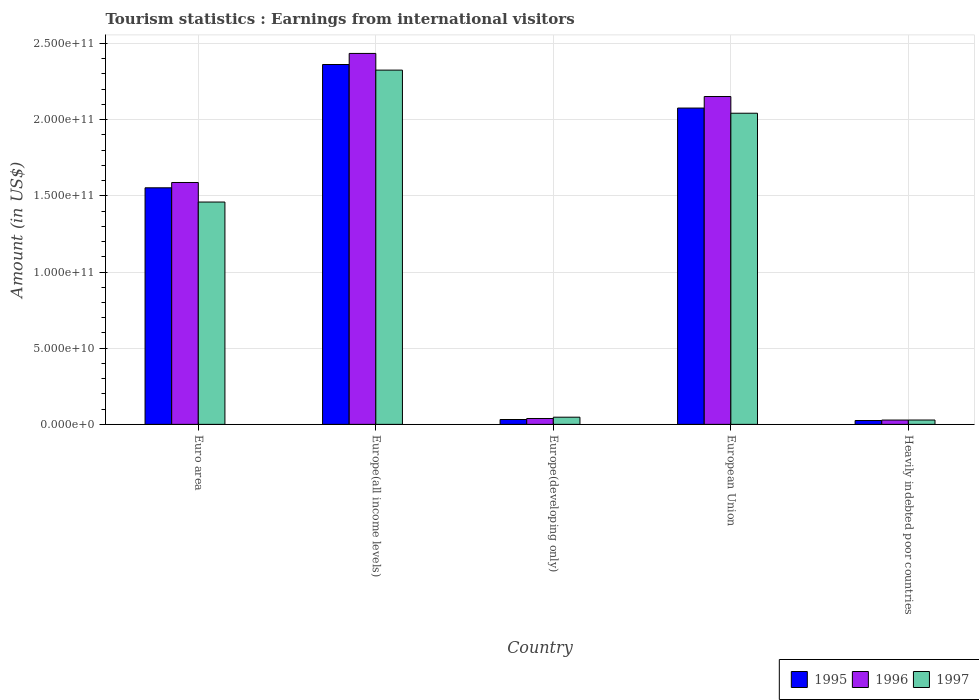How many groups of bars are there?
Ensure brevity in your answer.  5. Are the number of bars on each tick of the X-axis equal?
Your answer should be compact. Yes. What is the label of the 5th group of bars from the left?
Your answer should be very brief. Heavily indebted poor countries. What is the earnings from international visitors in 1996 in Europe(developing only)?
Provide a succinct answer. 3.86e+09. Across all countries, what is the maximum earnings from international visitors in 1997?
Keep it short and to the point. 2.33e+11. Across all countries, what is the minimum earnings from international visitors in 1996?
Provide a succinct answer. 2.83e+09. In which country was the earnings from international visitors in 1996 maximum?
Keep it short and to the point. Europe(all income levels). In which country was the earnings from international visitors in 1997 minimum?
Provide a succinct answer. Heavily indebted poor countries. What is the total earnings from international visitors in 1997 in the graph?
Your answer should be compact. 5.90e+11. What is the difference between the earnings from international visitors in 1996 in European Union and that in Heavily indebted poor countries?
Make the answer very short. 2.12e+11. What is the difference between the earnings from international visitors in 1996 in Euro area and the earnings from international visitors in 1997 in Europe(all income levels)?
Ensure brevity in your answer.  -7.38e+1. What is the average earnings from international visitors in 1997 per country?
Provide a short and direct response. 1.18e+11. What is the difference between the earnings from international visitors of/in 1996 and earnings from international visitors of/in 1997 in Heavily indebted poor countries?
Provide a succinct answer. -2.43e+07. In how many countries, is the earnings from international visitors in 1995 greater than 170000000000 US$?
Offer a very short reply. 2. What is the ratio of the earnings from international visitors in 1997 in Europe(developing only) to that in Heavily indebted poor countries?
Your answer should be compact. 1.65. Is the difference between the earnings from international visitors in 1996 in Europe(all income levels) and European Union greater than the difference between the earnings from international visitors in 1997 in Europe(all income levels) and European Union?
Ensure brevity in your answer.  Yes. What is the difference between the highest and the second highest earnings from international visitors in 1997?
Offer a very short reply. -2.83e+1. What is the difference between the highest and the lowest earnings from international visitors in 1995?
Provide a short and direct response. 2.34e+11. In how many countries, is the earnings from international visitors in 1997 greater than the average earnings from international visitors in 1997 taken over all countries?
Ensure brevity in your answer.  3. Is the sum of the earnings from international visitors in 1995 in European Union and Heavily indebted poor countries greater than the maximum earnings from international visitors in 1996 across all countries?
Offer a very short reply. No. What does the 3rd bar from the left in Europe(developing only) represents?
Your answer should be compact. 1997. What does the 1st bar from the right in Europe(developing only) represents?
Your answer should be very brief. 1997. Is it the case that in every country, the sum of the earnings from international visitors in 1995 and earnings from international visitors in 1996 is greater than the earnings from international visitors in 1997?
Ensure brevity in your answer.  Yes. Are all the bars in the graph horizontal?
Provide a short and direct response. No. Are the values on the major ticks of Y-axis written in scientific E-notation?
Make the answer very short. Yes. Does the graph contain grids?
Provide a short and direct response. Yes. Where does the legend appear in the graph?
Your answer should be very brief. Bottom right. How many legend labels are there?
Offer a very short reply. 3. What is the title of the graph?
Keep it short and to the point. Tourism statistics : Earnings from international visitors. What is the label or title of the Y-axis?
Keep it short and to the point. Amount (in US$). What is the Amount (in US$) of 1995 in Euro area?
Give a very brief answer. 1.55e+11. What is the Amount (in US$) in 1996 in Euro area?
Keep it short and to the point. 1.59e+11. What is the Amount (in US$) of 1997 in Euro area?
Your answer should be compact. 1.46e+11. What is the Amount (in US$) of 1995 in Europe(all income levels)?
Your response must be concise. 2.36e+11. What is the Amount (in US$) of 1996 in Europe(all income levels)?
Offer a very short reply. 2.43e+11. What is the Amount (in US$) in 1997 in Europe(all income levels)?
Give a very brief answer. 2.33e+11. What is the Amount (in US$) of 1995 in Europe(developing only)?
Give a very brief answer. 3.19e+09. What is the Amount (in US$) of 1996 in Europe(developing only)?
Offer a terse response. 3.86e+09. What is the Amount (in US$) in 1997 in Europe(developing only)?
Provide a succinct answer. 4.71e+09. What is the Amount (in US$) in 1995 in European Union?
Offer a terse response. 2.08e+11. What is the Amount (in US$) of 1996 in European Union?
Give a very brief answer. 2.15e+11. What is the Amount (in US$) of 1997 in European Union?
Give a very brief answer. 2.04e+11. What is the Amount (in US$) of 1995 in Heavily indebted poor countries?
Provide a short and direct response. 2.53e+09. What is the Amount (in US$) in 1996 in Heavily indebted poor countries?
Give a very brief answer. 2.83e+09. What is the Amount (in US$) in 1997 in Heavily indebted poor countries?
Make the answer very short. 2.86e+09. Across all countries, what is the maximum Amount (in US$) of 1995?
Your answer should be very brief. 2.36e+11. Across all countries, what is the maximum Amount (in US$) of 1996?
Your answer should be very brief. 2.43e+11. Across all countries, what is the maximum Amount (in US$) of 1997?
Your response must be concise. 2.33e+11. Across all countries, what is the minimum Amount (in US$) in 1995?
Your answer should be very brief. 2.53e+09. Across all countries, what is the minimum Amount (in US$) in 1996?
Keep it short and to the point. 2.83e+09. Across all countries, what is the minimum Amount (in US$) in 1997?
Offer a terse response. 2.86e+09. What is the total Amount (in US$) in 1995 in the graph?
Offer a terse response. 6.05e+11. What is the total Amount (in US$) of 1996 in the graph?
Your answer should be very brief. 6.24e+11. What is the total Amount (in US$) of 1997 in the graph?
Offer a very short reply. 5.90e+11. What is the difference between the Amount (in US$) in 1995 in Euro area and that in Europe(all income levels)?
Give a very brief answer. -8.09e+1. What is the difference between the Amount (in US$) in 1996 in Euro area and that in Europe(all income levels)?
Keep it short and to the point. -8.47e+1. What is the difference between the Amount (in US$) in 1997 in Euro area and that in Europe(all income levels)?
Ensure brevity in your answer.  -8.66e+1. What is the difference between the Amount (in US$) in 1995 in Euro area and that in Europe(developing only)?
Give a very brief answer. 1.52e+11. What is the difference between the Amount (in US$) in 1996 in Euro area and that in Europe(developing only)?
Your answer should be very brief. 1.55e+11. What is the difference between the Amount (in US$) of 1997 in Euro area and that in Europe(developing only)?
Keep it short and to the point. 1.41e+11. What is the difference between the Amount (in US$) in 1995 in Euro area and that in European Union?
Provide a short and direct response. -5.23e+1. What is the difference between the Amount (in US$) of 1996 in Euro area and that in European Union?
Offer a terse response. -5.64e+1. What is the difference between the Amount (in US$) of 1997 in Euro area and that in European Union?
Your answer should be very brief. -5.83e+1. What is the difference between the Amount (in US$) of 1995 in Euro area and that in Heavily indebted poor countries?
Give a very brief answer. 1.53e+11. What is the difference between the Amount (in US$) in 1996 in Euro area and that in Heavily indebted poor countries?
Your answer should be compact. 1.56e+11. What is the difference between the Amount (in US$) in 1997 in Euro area and that in Heavily indebted poor countries?
Your response must be concise. 1.43e+11. What is the difference between the Amount (in US$) of 1995 in Europe(all income levels) and that in Europe(developing only)?
Your answer should be very brief. 2.33e+11. What is the difference between the Amount (in US$) of 1996 in Europe(all income levels) and that in Europe(developing only)?
Your response must be concise. 2.40e+11. What is the difference between the Amount (in US$) in 1997 in Europe(all income levels) and that in Europe(developing only)?
Give a very brief answer. 2.28e+11. What is the difference between the Amount (in US$) in 1995 in Europe(all income levels) and that in European Union?
Your answer should be compact. 2.86e+1. What is the difference between the Amount (in US$) in 1996 in Europe(all income levels) and that in European Union?
Provide a short and direct response. 2.83e+1. What is the difference between the Amount (in US$) of 1997 in Europe(all income levels) and that in European Union?
Offer a terse response. 2.83e+1. What is the difference between the Amount (in US$) of 1995 in Europe(all income levels) and that in Heavily indebted poor countries?
Keep it short and to the point. 2.34e+11. What is the difference between the Amount (in US$) of 1996 in Europe(all income levels) and that in Heavily indebted poor countries?
Keep it short and to the point. 2.41e+11. What is the difference between the Amount (in US$) in 1997 in Europe(all income levels) and that in Heavily indebted poor countries?
Keep it short and to the point. 2.30e+11. What is the difference between the Amount (in US$) of 1995 in Europe(developing only) and that in European Union?
Provide a short and direct response. -2.04e+11. What is the difference between the Amount (in US$) in 1996 in Europe(developing only) and that in European Union?
Your response must be concise. -2.11e+11. What is the difference between the Amount (in US$) in 1997 in Europe(developing only) and that in European Union?
Offer a very short reply. -2.00e+11. What is the difference between the Amount (in US$) of 1995 in Europe(developing only) and that in Heavily indebted poor countries?
Make the answer very short. 6.57e+08. What is the difference between the Amount (in US$) of 1996 in Europe(developing only) and that in Heavily indebted poor countries?
Your answer should be very brief. 1.02e+09. What is the difference between the Amount (in US$) of 1997 in Europe(developing only) and that in Heavily indebted poor countries?
Ensure brevity in your answer.  1.85e+09. What is the difference between the Amount (in US$) of 1995 in European Union and that in Heavily indebted poor countries?
Your answer should be very brief. 2.05e+11. What is the difference between the Amount (in US$) of 1996 in European Union and that in Heavily indebted poor countries?
Ensure brevity in your answer.  2.12e+11. What is the difference between the Amount (in US$) in 1997 in European Union and that in Heavily indebted poor countries?
Your answer should be very brief. 2.01e+11. What is the difference between the Amount (in US$) of 1995 in Euro area and the Amount (in US$) of 1996 in Europe(all income levels)?
Offer a terse response. -8.82e+1. What is the difference between the Amount (in US$) in 1995 in Euro area and the Amount (in US$) in 1997 in Europe(all income levels)?
Make the answer very short. -7.72e+1. What is the difference between the Amount (in US$) of 1996 in Euro area and the Amount (in US$) of 1997 in Europe(all income levels)?
Offer a very short reply. -7.38e+1. What is the difference between the Amount (in US$) of 1995 in Euro area and the Amount (in US$) of 1996 in Europe(developing only)?
Your answer should be compact. 1.51e+11. What is the difference between the Amount (in US$) in 1995 in Euro area and the Amount (in US$) in 1997 in Europe(developing only)?
Offer a terse response. 1.51e+11. What is the difference between the Amount (in US$) in 1996 in Euro area and the Amount (in US$) in 1997 in Europe(developing only)?
Keep it short and to the point. 1.54e+11. What is the difference between the Amount (in US$) in 1995 in Euro area and the Amount (in US$) in 1996 in European Union?
Provide a succinct answer. -5.99e+1. What is the difference between the Amount (in US$) of 1995 in Euro area and the Amount (in US$) of 1997 in European Union?
Offer a very short reply. -4.90e+1. What is the difference between the Amount (in US$) in 1996 in Euro area and the Amount (in US$) in 1997 in European Union?
Provide a succinct answer. -4.55e+1. What is the difference between the Amount (in US$) in 1995 in Euro area and the Amount (in US$) in 1996 in Heavily indebted poor countries?
Your answer should be compact. 1.52e+11. What is the difference between the Amount (in US$) of 1995 in Euro area and the Amount (in US$) of 1997 in Heavily indebted poor countries?
Offer a terse response. 1.52e+11. What is the difference between the Amount (in US$) of 1996 in Euro area and the Amount (in US$) of 1997 in Heavily indebted poor countries?
Ensure brevity in your answer.  1.56e+11. What is the difference between the Amount (in US$) in 1995 in Europe(all income levels) and the Amount (in US$) in 1996 in Europe(developing only)?
Your answer should be compact. 2.32e+11. What is the difference between the Amount (in US$) of 1995 in Europe(all income levels) and the Amount (in US$) of 1997 in Europe(developing only)?
Your response must be concise. 2.31e+11. What is the difference between the Amount (in US$) of 1996 in Europe(all income levels) and the Amount (in US$) of 1997 in Europe(developing only)?
Give a very brief answer. 2.39e+11. What is the difference between the Amount (in US$) of 1995 in Europe(all income levels) and the Amount (in US$) of 1996 in European Union?
Keep it short and to the point. 2.10e+1. What is the difference between the Amount (in US$) in 1995 in Europe(all income levels) and the Amount (in US$) in 1997 in European Union?
Offer a terse response. 3.20e+1. What is the difference between the Amount (in US$) of 1996 in Europe(all income levels) and the Amount (in US$) of 1997 in European Union?
Make the answer very short. 3.92e+1. What is the difference between the Amount (in US$) of 1995 in Europe(all income levels) and the Amount (in US$) of 1996 in Heavily indebted poor countries?
Your answer should be very brief. 2.33e+11. What is the difference between the Amount (in US$) in 1995 in Europe(all income levels) and the Amount (in US$) in 1997 in Heavily indebted poor countries?
Your response must be concise. 2.33e+11. What is the difference between the Amount (in US$) of 1996 in Europe(all income levels) and the Amount (in US$) of 1997 in Heavily indebted poor countries?
Offer a terse response. 2.41e+11. What is the difference between the Amount (in US$) of 1995 in Europe(developing only) and the Amount (in US$) of 1996 in European Union?
Ensure brevity in your answer.  -2.12e+11. What is the difference between the Amount (in US$) of 1995 in Europe(developing only) and the Amount (in US$) of 1997 in European Union?
Provide a short and direct response. -2.01e+11. What is the difference between the Amount (in US$) of 1996 in Europe(developing only) and the Amount (in US$) of 1997 in European Union?
Your answer should be compact. -2.00e+11. What is the difference between the Amount (in US$) of 1995 in Europe(developing only) and the Amount (in US$) of 1996 in Heavily indebted poor countries?
Your response must be concise. 3.56e+08. What is the difference between the Amount (in US$) of 1995 in Europe(developing only) and the Amount (in US$) of 1997 in Heavily indebted poor countries?
Your response must be concise. 3.31e+08. What is the difference between the Amount (in US$) in 1996 in Europe(developing only) and the Amount (in US$) in 1997 in Heavily indebted poor countries?
Your answer should be very brief. 1.00e+09. What is the difference between the Amount (in US$) in 1995 in European Union and the Amount (in US$) in 1996 in Heavily indebted poor countries?
Provide a succinct answer. 2.05e+11. What is the difference between the Amount (in US$) of 1995 in European Union and the Amount (in US$) of 1997 in Heavily indebted poor countries?
Offer a very short reply. 2.05e+11. What is the difference between the Amount (in US$) of 1996 in European Union and the Amount (in US$) of 1997 in Heavily indebted poor countries?
Provide a succinct answer. 2.12e+11. What is the average Amount (in US$) in 1995 per country?
Offer a terse response. 1.21e+11. What is the average Amount (in US$) in 1996 per country?
Make the answer very short. 1.25e+11. What is the average Amount (in US$) of 1997 per country?
Ensure brevity in your answer.  1.18e+11. What is the difference between the Amount (in US$) in 1995 and Amount (in US$) in 1996 in Euro area?
Make the answer very short. -3.48e+09. What is the difference between the Amount (in US$) of 1995 and Amount (in US$) of 1997 in Euro area?
Your response must be concise. 9.35e+09. What is the difference between the Amount (in US$) in 1996 and Amount (in US$) in 1997 in Euro area?
Offer a very short reply. 1.28e+1. What is the difference between the Amount (in US$) in 1995 and Amount (in US$) in 1996 in Europe(all income levels)?
Make the answer very short. -7.28e+09. What is the difference between the Amount (in US$) of 1995 and Amount (in US$) of 1997 in Europe(all income levels)?
Provide a succinct answer. 3.68e+09. What is the difference between the Amount (in US$) of 1996 and Amount (in US$) of 1997 in Europe(all income levels)?
Keep it short and to the point. 1.10e+1. What is the difference between the Amount (in US$) in 1995 and Amount (in US$) in 1996 in Europe(developing only)?
Your answer should be very brief. -6.68e+08. What is the difference between the Amount (in US$) in 1995 and Amount (in US$) in 1997 in Europe(developing only)?
Provide a short and direct response. -1.52e+09. What is the difference between the Amount (in US$) in 1996 and Amount (in US$) in 1997 in Europe(developing only)?
Your answer should be very brief. -8.51e+08. What is the difference between the Amount (in US$) of 1995 and Amount (in US$) of 1996 in European Union?
Provide a short and direct response. -7.57e+09. What is the difference between the Amount (in US$) of 1995 and Amount (in US$) of 1997 in European Union?
Your answer should be very brief. 3.39e+09. What is the difference between the Amount (in US$) of 1996 and Amount (in US$) of 1997 in European Union?
Offer a terse response. 1.10e+1. What is the difference between the Amount (in US$) of 1995 and Amount (in US$) of 1996 in Heavily indebted poor countries?
Offer a very short reply. -3.01e+08. What is the difference between the Amount (in US$) in 1995 and Amount (in US$) in 1997 in Heavily indebted poor countries?
Make the answer very short. -3.25e+08. What is the difference between the Amount (in US$) in 1996 and Amount (in US$) in 1997 in Heavily indebted poor countries?
Provide a succinct answer. -2.43e+07. What is the ratio of the Amount (in US$) in 1995 in Euro area to that in Europe(all income levels)?
Make the answer very short. 0.66. What is the ratio of the Amount (in US$) in 1996 in Euro area to that in Europe(all income levels)?
Your response must be concise. 0.65. What is the ratio of the Amount (in US$) in 1997 in Euro area to that in Europe(all income levels)?
Provide a short and direct response. 0.63. What is the ratio of the Amount (in US$) of 1995 in Euro area to that in Europe(developing only)?
Provide a succinct answer. 48.69. What is the ratio of the Amount (in US$) in 1996 in Euro area to that in Europe(developing only)?
Provide a succinct answer. 41.15. What is the ratio of the Amount (in US$) in 1997 in Euro area to that in Europe(developing only)?
Keep it short and to the point. 30.99. What is the ratio of the Amount (in US$) in 1995 in Euro area to that in European Union?
Your answer should be compact. 0.75. What is the ratio of the Amount (in US$) of 1996 in Euro area to that in European Union?
Give a very brief answer. 0.74. What is the ratio of the Amount (in US$) in 1997 in Euro area to that in European Union?
Your answer should be very brief. 0.71. What is the ratio of the Amount (in US$) in 1995 in Euro area to that in Heavily indebted poor countries?
Provide a short and direct response. 61.31. What is the ratio of the Amount (in US$) in 1996 in Euro area to that in Heavily indebted poor countries?
Provide a succinct answer. 56.03. What is the ratio of the Amount (in US$) in 1997 in Euro area to that in Heavily indebted poor countries?
Provide a succinct answer. 51.06. What is the ratio of the Amount (in US$) of 1995 in Europe(all income levels) to that in Europe(developing only)?
Make the answer very short. 74.06. What is the ratio of the Amount (in US$) of 1996 in Europe(all income levels) to that in Europe(developing only)?
Keep it short and to the point. 63.11. What is the ratio of the Amount (in US$) of 1997 in Europe(all income levels) to that in Europe(developing only)?
Offer a terse response. 49.38. What is the ratio of the Amount (in US$) of 1995 in Europe(all income levels) to that in European Union?
Your answer should be compact. 1.14. What is the ratio of the Amount (in US$) in 1996 in Europe(all income levels) to that in European Union?
Your response must be concise. 1.13. What is the ratio of the Amount (in US$) of 1997 in Europe(all income levels) to that in European Union?
Your answer should be compact. 1.14. What is the ratio of the Amount (in US$) of 1995 in Europe(all income levels) to that in Heavily indebted poor countries?
Give a very brief answer. 93.26. What is the ratio of the Amount (in US$) of 1996 in Europe(all income levels) to that in Heavily indebted poor countries?
Provide a short and direct response. 85.92. What is the ratio of the Amount (in US$) in 1997 in Europe(all income levels) to that in Heavily indebted poor countries?
Offer a terse response. 81.36. What is the ratio of the Amount (in US$) of 1995 in Europe(developing only) to that in European Union?
Keep it short and to the point. 0.02. What is the ratio of the Amount (in US$) in 1996 in Europe(developing only) to that in European Union?
Provide a short and direct response. 0.02. What is the ratio of the Amount (in US$) in 1997 in Europe(developing only) to that in European Union?
Offer a very short reply. 0.02. What is the ratio of the Amount (in US$) of 1995 in Europe(developing only) to that in Heavily indebted poor countries?
Offer a very short reply. 1.26. What is the ratio of the Amount (in US$) in 1996 in Europe(developing only) to that in Heavily indebted poor countries?
Your answer should be very brief. 1.36. What is the ratio of the Amount (in US$) in 1997 in Europe(developing only) to that in Heavily indebted poor countries?
Provide a short and direct response. 1.65. What is the ratio of the Amount (in US$) in 1995 in European Union to that in Heavily indebted poor countries?
Your answer should be very brief. 81.97. What is the ratio of the Amount (in US$) in 1996 in European Union to that in Heavily indebted poor countries?
Ensure brevity in your answer.  75.94. What is the ratio of the Amount (in US$) of 1997 in European Union to that in Heavily indebted poor countries?
Offer a very short reply. 71.46. What is the difference between the highest and the second highest Amount (in US$) of 1995?
Ensure brevity in your answer.  2.86e+1. What is the difference between the highest and the second highest Amount (in US$) of 1996?
Provide a succinct answer. 2.83e+1. What is the difference between the highest and the second highest Amount (in US$) in 1997?
Provide a succinct answer. 2.83e+1. What is the difference between the highest and the lowest Amount (in US$) in 1995?
Your answer should be compact. 2.34e+11. What is the difference between the highest and the lowest Amount (in US$) in 1996?
Ensure brevity in your answer.  2.41e+11. What is the difference between the highest and the lowest Amount (in US$) of 1997?
Keep it short and to the point. 2.30e+11. 